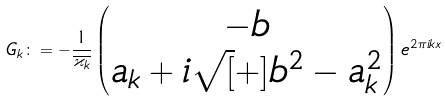Convert formula to latex. <formula><loc_0><loc_0><loc_500><loc_500>G _ { k } \colon = - \frac { 1 } { \overline { \varkappa _ { k } } } \begin{pmatrix} - b \\ a _ { k } + i \sqrt { [ } + ] { b ^ { 2 } - a _ { k } ^ { 2 } } \end{pmatrix} e ^ { 2 \pi i k x }</formula> 